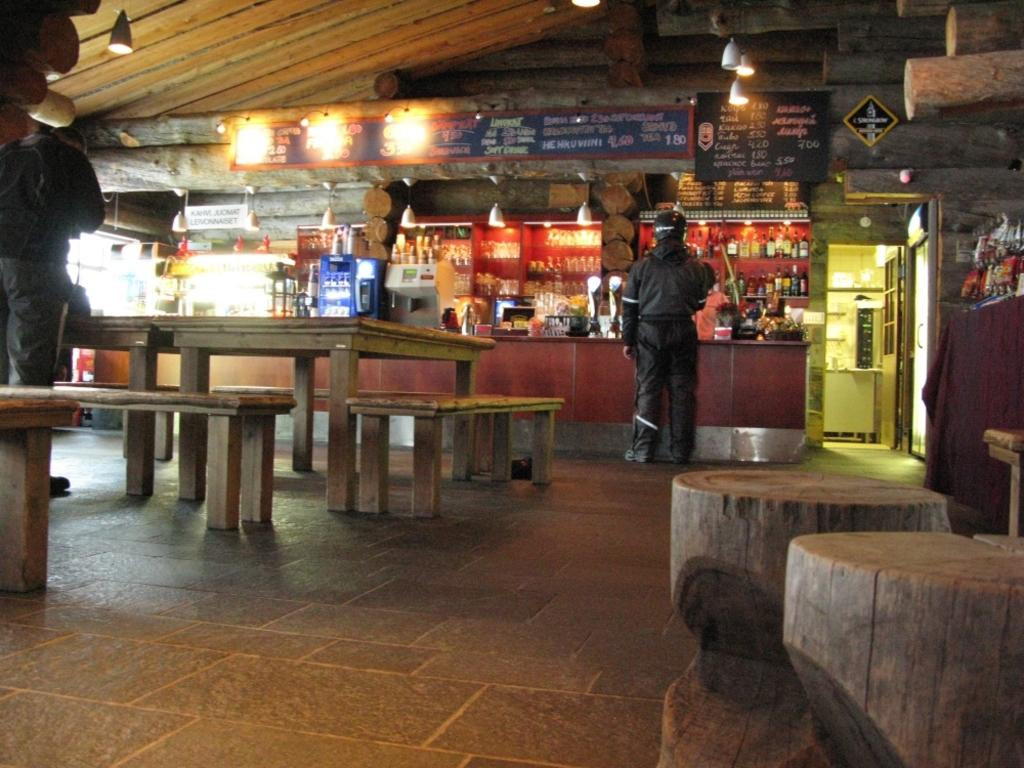What can be seen in the image in terms of human presence? There are people standing in the image. What type of furniture is present in the image? There are benches and tables in the image. Is there a lamp being used in a battle scene in the image? There is no lamp or battle scene present in the image. Can you see any mines in the image? There are no mines visible in the image. 